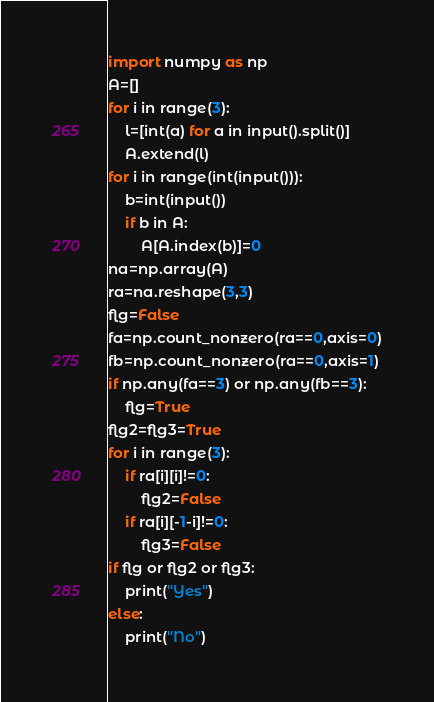Convert code to text. <code><loc_0><loc_0><loc_500><loc_500><_Python_>import numpy as np
A=[]
for i in range(3):
    l=[int(a) for a in input().split()]
    A.extend(l)
for i in range(int(input())):
    b=int(input())
    if b in A:
        A[A.index(b)]=0
na=np.array(A)
ra=na.reshape(3,3)
flg=False
fa=np.count_nonzero(ra==0,axis=0)
fb=np.count_nonzero(ra==0,axis=1)
if np.any(fa==3) or np.any(fb==3):
    flg=True
flg2=flg3=True    
for i in range(3):
    if ra[i][i]!=0:
        flg2=False
    if ra[i][-1-i]!=0:
        flg3=False
if flg or flg2 or flg3:
    print("Yes")
else:
    print("No")</code> 